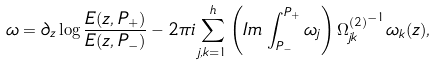Convert formula to latex. <formula><loc_0><loc_0><loc_500><loc_500>\omega = \partial _ { z } \log { \frac { E ( z , P _ { + } ) } { E ( z , P _ { - } ) } } - 2 \pi i \sum _ { j , k = 1 } ^ { h } \left ( I m \, \int _ { P _ { - } } ^ { P _ { + } } \omega _ { j } \right ) { \Omega _ { j k } ^ { ( 2 ) } } ^ { - 1 } \omega _ { k } ( z ) ,</formula> 